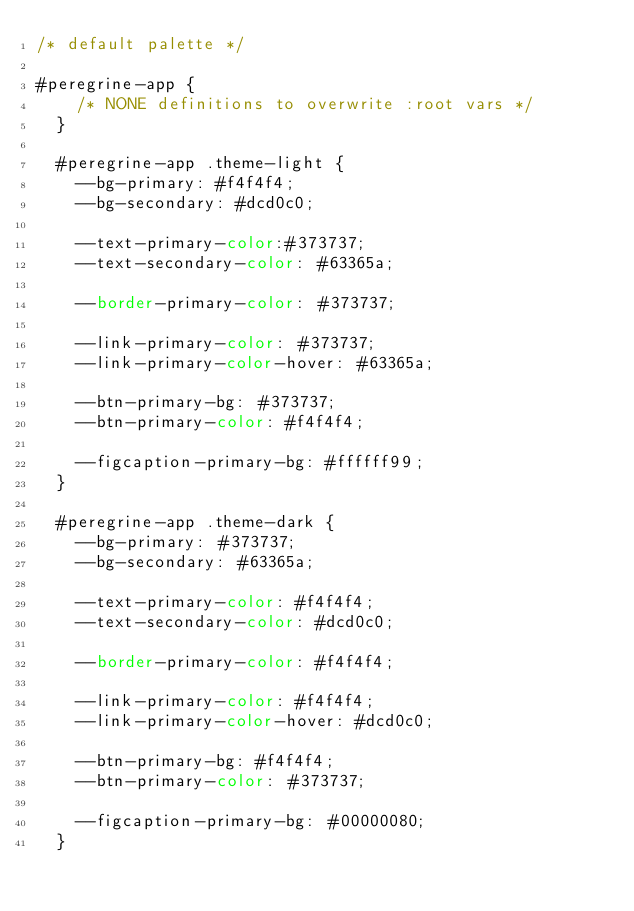Convert code to text. <code><loc_0><loc_0><loc_500><loc_500><_CSS_>/* default palette */

#peregrine-app {
    /* NONE definitions to overwrite :root vars */
  }
  
  #peregrine-app .theme-light {
    --bg-primary: #f4f4f4;
    --bg-secondary: #dcd0c0;
  
    --text-primary-color:#373737;
    --text-secondary-color: #63365a;
  
    --border-primary-color: #373737;
  
    --link-primary-color: #373737;
    --link-primary-color-hover: #63365a;
  
    --btn-primary-bg: #373737;
    --btn-primary-color: #f4f4f4;
  
    --figcaption-primary-bg: #ffffff99;
  }
  
  #peregrine-app .theme-dark {
    --bg-primary: #373737;
    --bg-secondary: #63365a;
  
    --text-primary-color: #f4f4f4;
    --text-secondary-color: #dcd0c0;
  
    --border-primary-color: #f4f4f4;
  
    --link-primary-color: #f4f4f4;
    --link-primary-color-hover: #dcd0c0;
  
    --btn-primary-bg: #f4f4f4;
    --btn-primary-color: #373737;
  
    --figcaption-primary-bg: #00000080;
  }</code> 